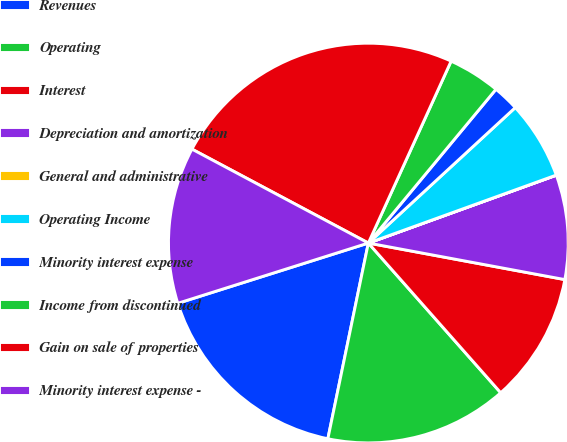<chart> <loc_0><loc_0><loc_500><loc_500><pie_chart><fcel>Revenues<fcel>Operating<fcel>Interest<fcel>Depreciation and amortization<fcel>General and administrative<fcel>Operating Income<fcel>Minority interest expense<fcel>Income from discontinued<fcel>Gain on sale of properties<fcel>Minority interest expense -<nl><fcel>16.88%<fcel>14.77%<fcel>10.55%<fcel>8.44%<fcel>0.01%<fcel>6.33%<fcel>2.12%<fcel>4.23%<fcel>24.01%<fcel>12.66%<nl></chart> 